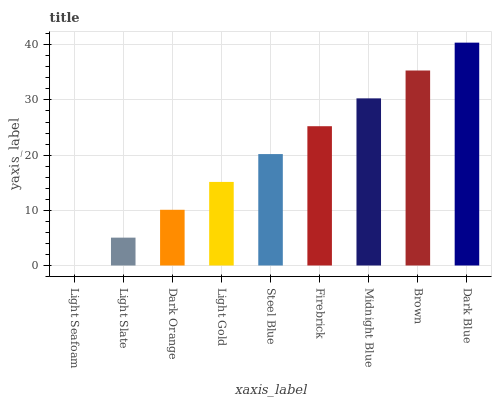Is Light Slate the minimum?
Answer yes or no. No. Is Light Slate the maximum?
Answer yes or no. No. Is Light Slate greater than Light Seafoam?
Answer yes or no. Yes. Is Light Seafoam less than Light Slate?
Answer yes or no. Yes. Is Light Seafoam greater than Light Slate?
Answer yes or no. No. Is Light Slate less than Light Seafoam?
Answer yes or no. No. Is Steel Blue the high median?
Answer yes or no. Yes. Is Steel Blue the low median?
Answer yes or no. Yes. Is Light Gold the high median?
Answer yes or no. No. Is Midnight Blue the low median?
Answer yes or no. No. 